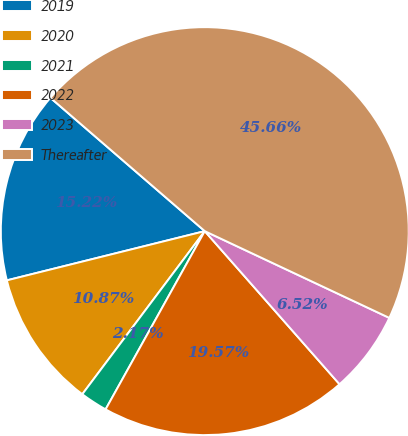Convert chart. <chart><loc_0><loc_0><loc_500><loc_500><pie_chart><fcel>2019<fcel>2020<fcel>2021<fcel>2022<fcel>2023<fcel>Thereafter<nl><fcel>15.22%<fcel>10.87%<fcel>2.17%<fcel>19.57%<fcel>6.52%<fcel>45.66%<nl></chart> 